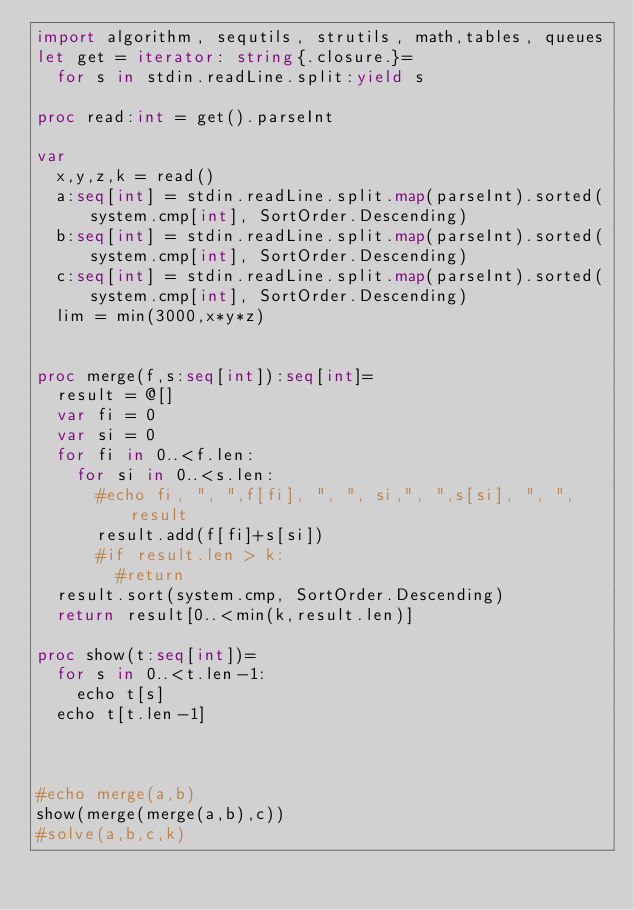Convert code to text. <code><loc_0><loc_0><loc_500><loc_500><_Nim_>import algorithm, sequtils, strutils, math,tables, queues
let get = iterator: string{.closure.}=
  for s in stdin.readLine.split:yield s
 
proc read:int = get().parseInt

var
  x,y,z,k = read()
  a:seq[int] = stdin.readLine.split.map(parseInt).sorted(system.cmp[int], SortOrder.Descending)
  b:seq[int] = stdin.readLine.split.map(parseInt).sorted(system.cmp[int], SortOrder.Descending)
  c:seq[int] = stdin.readLine.split.map(parseInt).sorted(system.cmp[int], SortOrder.Descending)
  lim = min(3000,x*y*z)


proc merge(f,s:seq[int]):seq[int]=
  result = @[]
  var fi = 0
  var si = 0
  for fi in 0..<f.len:
    for si in 0..<s.len:
      #echo fi, ", ",f[fi], ", ", si,", ",s[si], ", ", result
      result.add(f[fi]+s[si])
      #if result.len > k:
        #return
  result.sort(system.cmp, SortOrder.Descending)
  return result[0..<min(k,result.len)]

proc show(t:seq[int])=
  for s in 0..<t.len-1:
    echo t[s]
  echo t[t.len-1]
  
  

#echo merge(a,b)
show(merge(merge(a,b),c))
#solve(a,b,c,k)</code> 